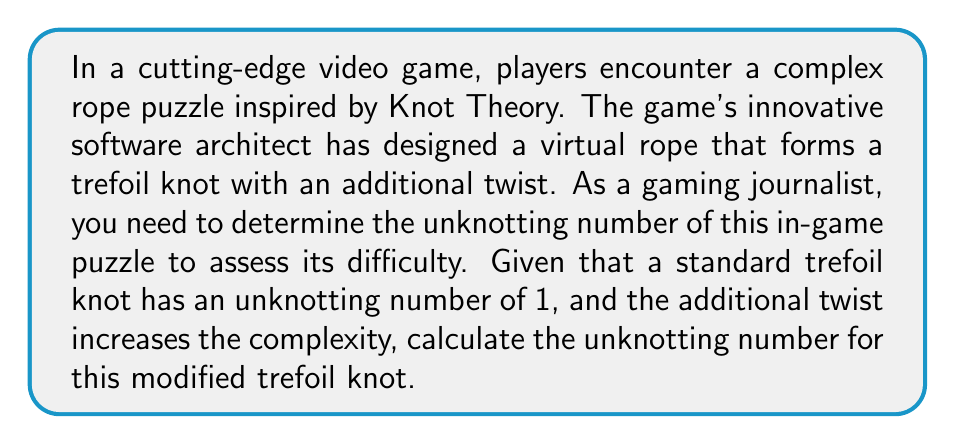Give your solution to this math problem. To solve this problem, we'll follow these steps:

1. Recall that the unknotting number of a knot is the minimum number of crossing changes required to transform the knot into an unknot (trivial knot).

2. A standard trefoil knot has an unknotting number of 1. This means one crossing change is sufficient to unknot it.

3. The additional twist in the game's rope puzzle adds complexity. In Knot Theory, this can be represented as an additional crossing.

4. To analyze the effect of the additional twist, we need to consider two cases:
   a) The twist creates a crossing that can be resolved independently.
   b) The twist interacts with the existing trefoil structure.

5. In case (a), we would need one move to unknot the trefoil and one move to resolve the additional twist, resulting in an unknotting number of 2.

6. In case (b), the additional twist could potentially be resolved simultaneously with one of the trefoil's crossings, maintaining an unknotting number of 1.

7. However, given that this is a complex in-game puzzle designed to challenge players, it's more likely that the software architect has implemented case (a) to increase difficulty.

8. Therefore, we can conclude that the unknotting number for this modified trefoil knot is 2.

This can be represented mathematically as:

$$u(K_{\text{modified}}) = u(K_{\text{trefoil}}) + u(K_{\text{additional twist}}) = 1 + 1 = 2$$

Where $u(K)$ represents the unknotting number of knot $K$.
Answer: 2 